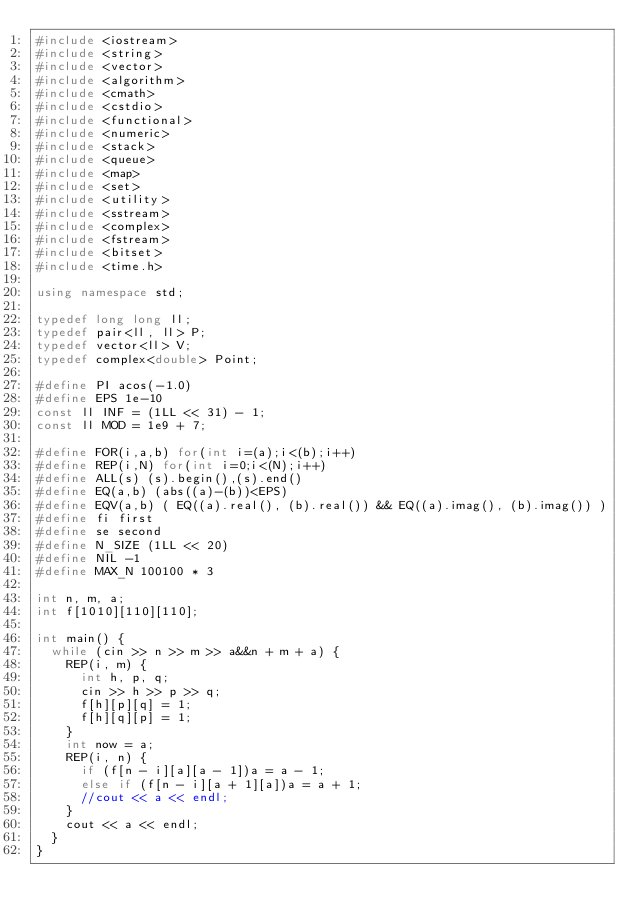Convert code to text. <code><loc_0><loc_0><loc_500><loc_500><_C++_>#include <iostream>
#include <string>
#include <vector>
#include <algorithm>
#include <cmath>
#include <cstdio>
#include <functional>
#include <numeric>
#include <stack>
#include <queue>
#include <map>
#include <set>
#include <utility>
#include <sstream>
#include <complex>
#include <fstream>
#include <bitset>
#include <time.h>

using namespace std;

typedef long long ll;
typedef pair<ll, ll> P;
typedef vector<ll> V;
typedef complex<double> Point;

#define PI acos(-1.0)
#define EPS 1e-10
const ll INF = (1LL << 31) - 1;
const ll MOD = 1e9 + 7;

#define FOR(i,a,b) for(int i=(a);i<(b);i++)
#define REP(i,N) for(int i=0;i<(N);i++)
#define ALL(s) (s).begin(),(s).end()
#define EQ(a,b) (abs((a)-(b))<EPS)
#define EQV(a,b) ( EQ((a).real(), (b).real()) && EQ((a).imag(), (b).imag()) )
#define fi first
#define se second
#define N_SIZE (1LL << 20)
#define NIL -1
#define MAX_N 100100 * 3

int n, m, a;
int f[1010][110][110];

int main() {
	while (cin >> n >> m >> a&&n + m + a) {
		REP(i, m) {
			int h, p, q;
			cin >> h >> p >> q;
			f[h][p][q] = 1;
			f[h][q][p] = 1;
		}
		int now = a;
		REP(i, n) {
			if (f[n - i][a][a - 1])a = a - 1;
			else if (f[n - i][a + 1][a])a = a + 1;
			//cout << a << endl;
		}
		cout << a << endl;
	}
}</code> 